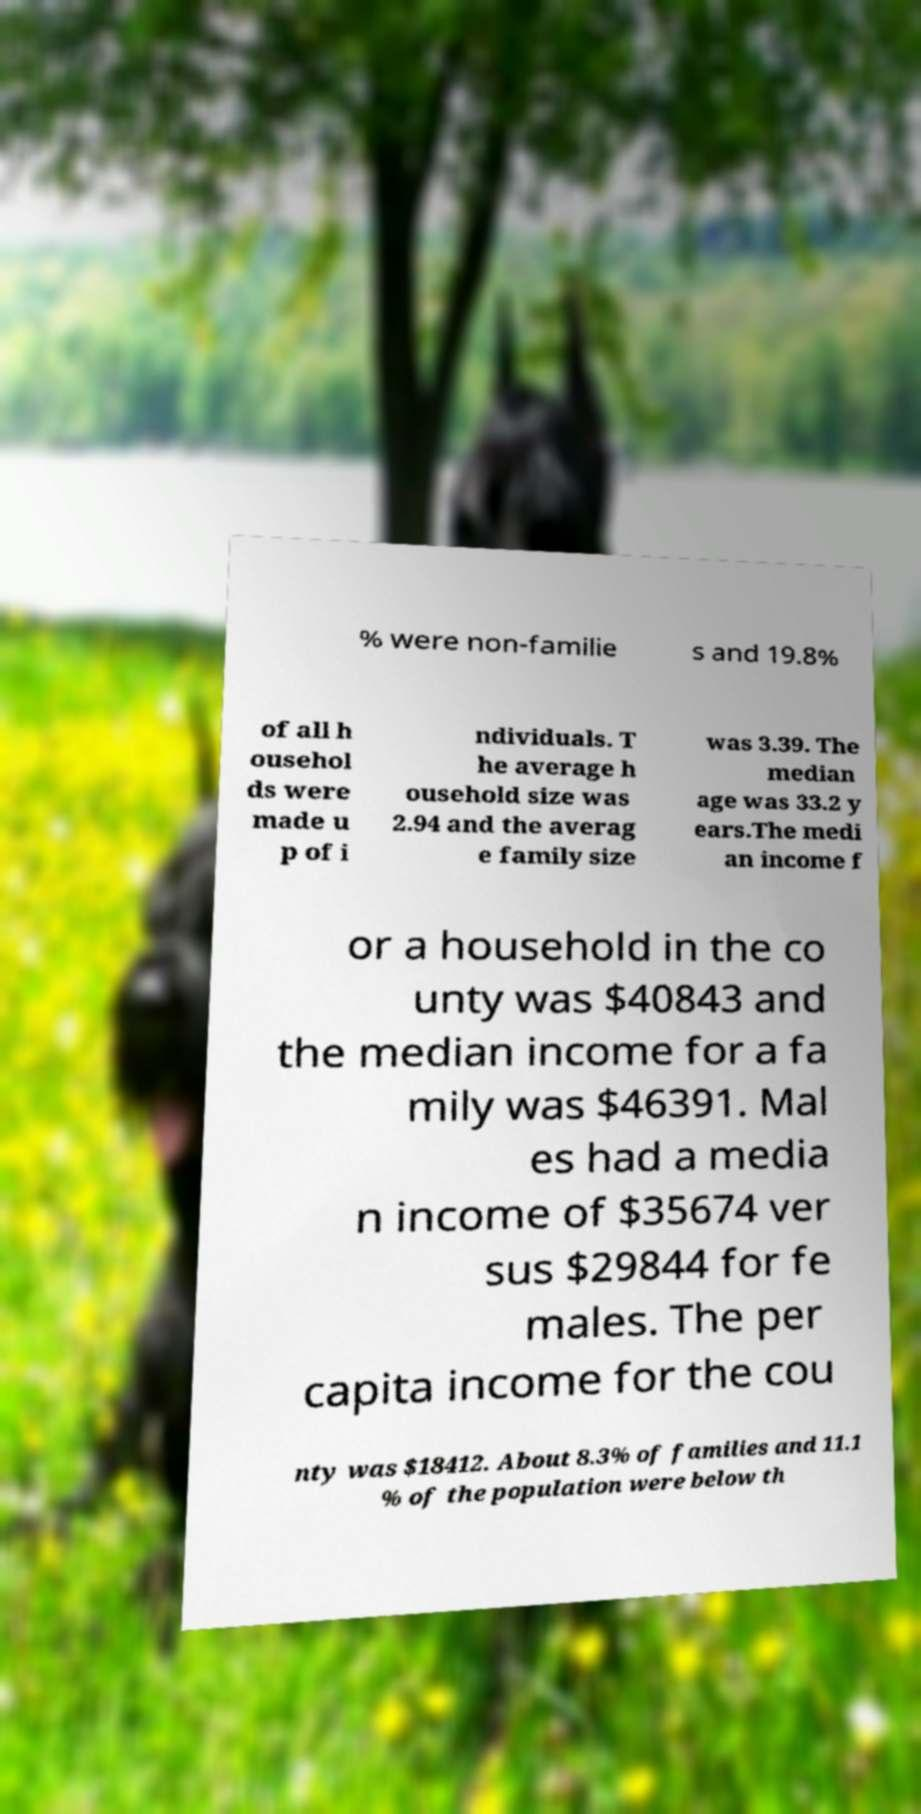There's text embedded in this image that I need extracted. Can you transcribe it verbatim? % were non-familie s and 19.8% of all h ousehol ds were made u p of i ndividuals. T he average h ousehold size was 2.94 and the averag e family size was 3.39. The median age was 33.2 y ears.The medi an income f or a household in the co unty was $40843 and the median income for a fa mily was $46391. Mal es had a media n income of $35674 ver sus $29844 for fe males. The per capita income for the cou nty was $18412. About 8.3% of families and 11.1 % of the population were below th 